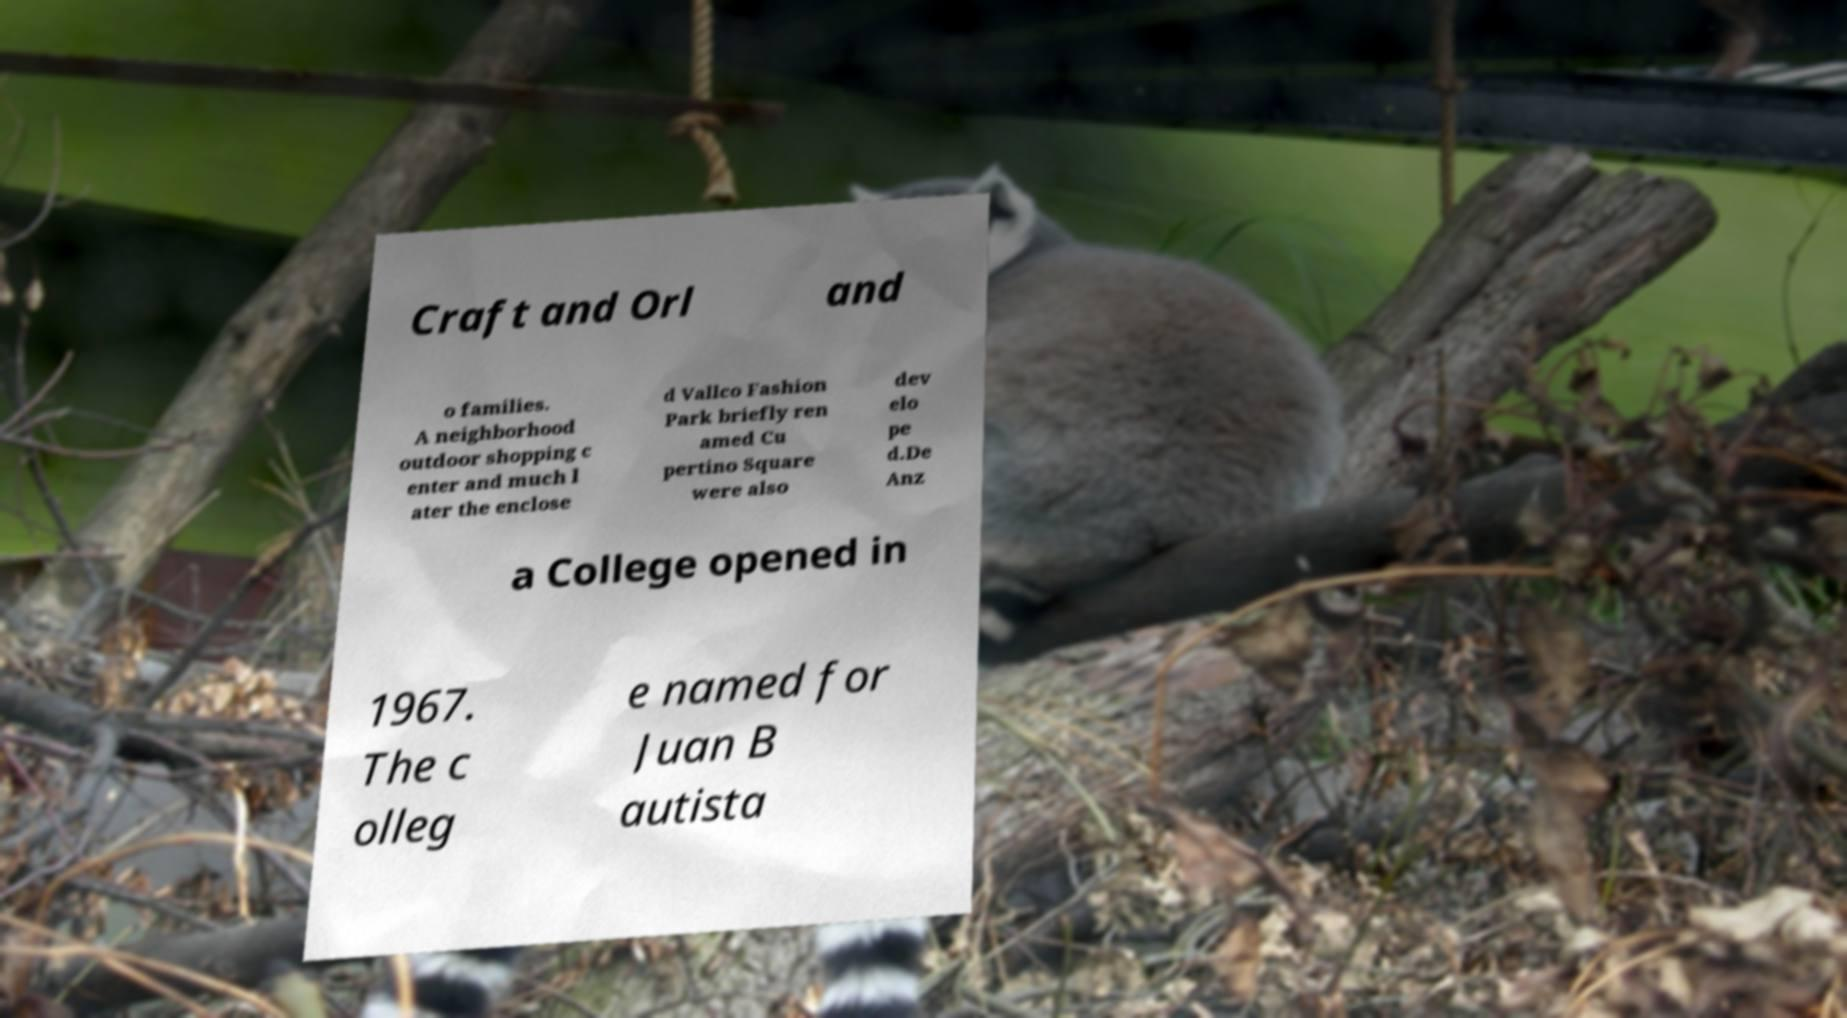Please identify and transcribe the text found in this image. Craft and Orl and o families. A neighborhood outdoor shopping c enter and much l ater the enclose d Vallco Fashion Park briefly ren amed Cu pertino Square were also dev elo pe d.De Anz a College opened in 1967. The c olleg e named for Juan B autista 